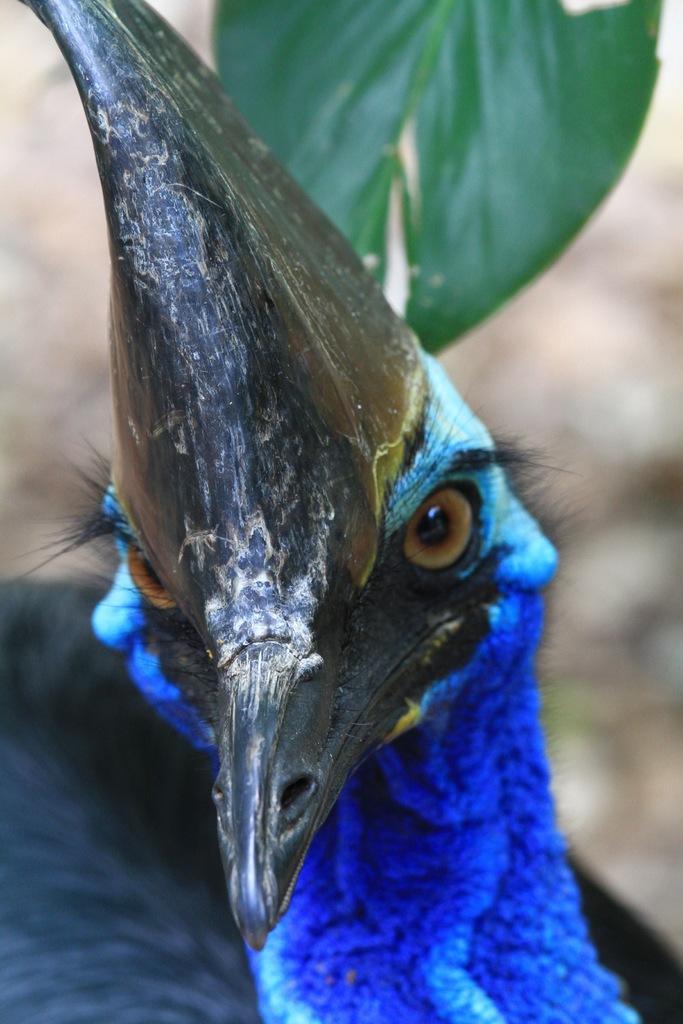Can you describe this image briefly? In the center of the image, we can see a peacock and in the background, there is a leaf. 